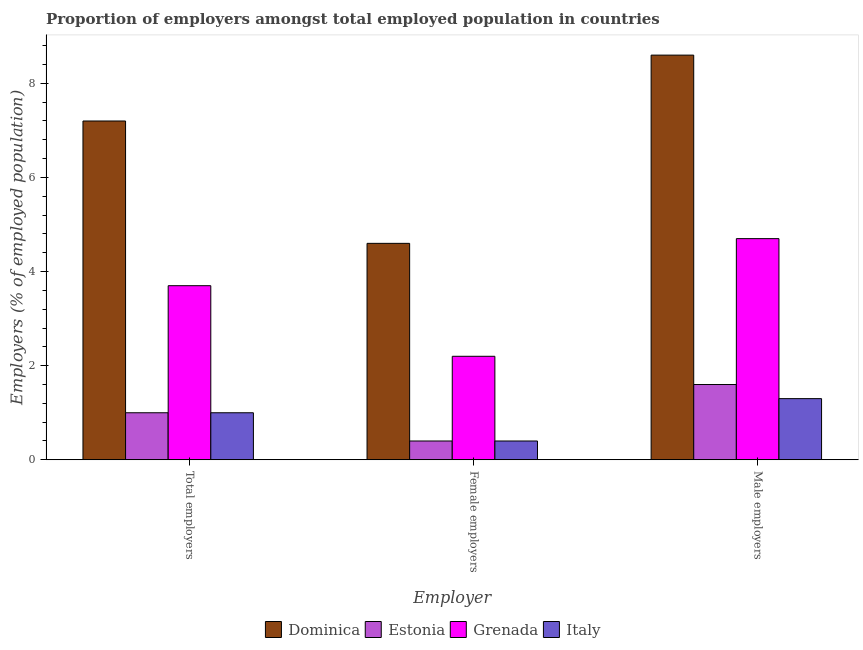How many groups of bars are there?
Offer a very short reply. 3. Are the number of bars per tick equal to the number of legend labels?
Provide a succinct answer. Yes. Are the number of bars on each tick of the X-axis equal?
Your answer should be very brief. Yes. How many bars are there on the 2nd tick from the left?
Your response must be concise. 4. What is the label of the 1st group of bars from the left?
Offer a terse response. Total employers. What is the percentage of female employers in Estonia?
Give a very brief answer. 0.4. Across all countries, what is the maximum percentage of female employers?
Offer a terse response. 4.6. Across all countries, what is the minimum percentage of male employers?
Your response must be concise. 1.3. In which country was the percentage of total employers maximum?
Keep it short and to the point. Dominica. In which country was the percentage of female employers minimum?
Offer a terse response. Estonia. What is the total percentage of female employers in the graph?
Make the answer very short. 7.6. What is the difference between the percentage of male employers in Italy and that in Dominica?
Offer a terse response. -7.3. What is the difference between the percentage of male employers in Dominica and the percentage of total employers in Estonia?
Provide a short and direct response. 7.6. What is the average percentage of male employers per country?
Offer a terse response. 4.05. What is the difference between the percentage of total employers and percentage of male employers in Grenada?
Offer a terse response. -1. What is the ratio of the percentage of female employers in Italy to that in Estonia?
Offer a terse response. 1. Is the difference between the percentage of total employers in Italy and Estonia greater than the difference between the percentage of female employers in Italy and Estonia?
Provide a short and direct response. No. What is the difference between the highest and the second highest percentage of total employers?
Your answer should be compact. 3.5. What is the difference between the highest and the lowest percentage of female employers?
Your response must be concise. 4.2. In how many countries, is the percentage of male employers greater than the average percentage of male employers taken over all countries?
Make the answer very short. 2. What does the 1st bar from the left in Female employers represents?
Make the answer very short. Dominica. What does the 1st bar from the right in Male employers represents?
Your answer should be compact. Italy. Is it the case that in every country, the sum of the percentage of total employers and percentage of female employers is greater than the percentage of male employers?
Ensure brevity in your answer.  No. How many bars are there?
Your response must be concise. 12. Are all the bars in the graph horizontal?
Your answer should be very brief. No. Are the values on the major ticks of Y-axis written in scientific E-notation?
Keep it short and to the point. No. Does the graph contain any zero values?
Give a very brief answer. No. Where does the legend appear in the graph?
Give a very brief answer. Bottom center. How are the legend labels stacked?
Make the answer very short. Horizontal. What is the title of the graph?
Provide a short and direct response. Proportion of employers amongst total employed population in countries. Does "Estonia" appear as one of the legend labels in the graph?
Keep it short and to the point. Yes. What is the label or title of the X-axis?
Your response must be concise. Employer. What is the label or title of the Y-axis?
Your answer should be very brief. Employers (% of employed population). What is the Employers (% of employed population) of Dominica in Total employers?
Offer a very short reply. 7.2. What is the Employers (% of employed population) in Estonia in Total employers?
Provide a succinct answer. 1. What is the Employers (% of employed population) of Grenada in Total employers?
Offer a terse response. 3.7. What is the Employers (% of employed population) of Italy in Total employers?
Offer a very short reply. 1. What is the Employers (% of employed population) of Dominica in Female employers?
Offer a very short reply. 4.6. What is the Employers (% of employed population) of Estonia in Female employers?
Give a very brief answer. 0.4. What is the Employers (% of employed population) of Grenada in Female employers?
Your answer should be compact. 2.2. What is the Employers (% of employed population) in Italy in Female employers?
Your answer should be compact. 0.4. What is the Employers (% of employed population) of Dominica in Male employers?
Your answer should be compact. 8.6. What is the Employers (% of employed population) of Estonia in Male employers?
Give a very brief answer. 1.6. What is the Employers (% of employed population) in Grenada in Male employers?
Your answer should be compact. 4.7. What is the Employers (% of employed population) in Italy in Male employers?
Ensure brevity in your answer.  1.3. Across all Employer, what is the maximum Employers (% of employed population) in Dominica?
Your answer should be very brief. 8.6. Across all Employer, what is the maximum Employers (% of employed population) in Estonia?
Offer a very short reply. 1.6. Across all Employer, what is the maximum Employers (% of employed population) of Grenada?
Ensure brevity in your answer.  4.7. Across all Employer, what is the maximum Employers (% of employed population) of Italy?
Make the answer very short. 1.3. Across all Employer, what is the minimum Employers (% of employed population) of Dominica?
Make the answer very short. 4.6. Across all Employer, what is the minimum Employers (% of employed population) of Estonia?
Your answer should be very brief. 0.4. Across all Employer, what is the minimum Employers (% of employed population) of Grenada?
Your response must be concise. 2.2. Across all Employer, what is the minimum Employers (% of employed population) in Italy?
Give a very brief answer. 0.4. What is the total Employers (% of employed population) of Dominica in the graph?
Your response must be concise. 20.4. What is the total Employers (% of employed population) in Italy in the graph?
Provide a short and direct response. 2.7. What is the difference between the Employers (% of employed population) of Dominica in Total employers and that in Female employers?
Offer a terse response. 2.6. What is the difference between the Employers (% of employed population) of Estonia in Total employers and that in Female employers?
Provide a succinct answer. 0.6. What is the difference between the Employers (% of employed population) of Grenada in Total employers and that in Female employers?
Provide a short and direct response. 1.5. What is the difference between the Employers (% of employed population) in Italy in Total employers and that in Female employers?
Keep it short and to the point. 0.6. What is the difference between the Employers (% of employed population) in Estonia in Total employers and that in Male employers?
Offer a very short reply. -0.6. What is the difference between the Employers (% of employed population) of Italy in Total employers and that in Male employers?
Ensure brevity in your answer.  -0.3. What is the difference between the Employers (% of employed population) in Dominica in Female employers and that in Male employers?
Your answer should be compact. -4. What is the difference between the Employers (% of employed population) of Estonia in Female employers and that in Male employers?
Provide a succinct answer. -1.2. What is the difference between the Employers (% of employed population) of Grenada in Female employers and that in Male employers?
Your answer should be compact. -2.5. What is the difference between the Employers (% of employed population) of Italy in Female employers and that in Male employers?
Offer a very short reply. -0.9. What is the difference between the Employers (% of employed population) in Dominica in Total employers and the Employers (% of employed population) in Estonia in Female employers?
Ensure brevity in your answer.  6.8. What is the difference between the Employers (% of employed population) of Estonia in Total employers and the Employers (% of employed population) of Grenada in Female employers?
Your answer should be very brief. -1.2. What is the difference between the Employers (% of employed population) of Estonia in Total employers and the Employers (% of employed population) of Italy in Female employers?
Offer a terse response. 0.6. What is the difference between the Employers (% of employed population) of Dominica in Total employers and the Employers (% of employed population) of Estonia in Male employers?
Make the answer very short. 5.6. What is the difference between the Employers (% of employed population) in Dominica in Total employers and the Employers (% of employed population) in Grenada in Male employers?
Offer a very short reply. 2.5. What is the difference between the Employers (% of employed population) in Dominica in Female employers and the Employers (% of employed population) in Estonia in Male employers?
Give a very brief answer. 3. What is the difference between the Employers (% of employed population) in Dominica in Female employers and the Employers (% of employed population) in Grenada in Male employers?
Give a very brief answer. -0.1. What is the difference between the Employers (% of employed population) of Dominica in Female employers and the Employers (% of employed population) of Italy in Male employers?
Keep it short and to the point. 3.3. What is the difference between the Employers (% of employed population) in Estonia in Female employers and the Employers (% of employed population) in Grenada in Male employers?
Ensure brevity in your answer.  -4.3. What is the average Employers (% of employed population) of Grenada per Employer?
Offer a terse response. 3.53. What is the difference between the Employers (% of employed population) in Dominica and Employers (% of employed population) in Estonia in Total employers?
Offer a terse response. 6.2. What is the difference between the Employers (% of employed population) in Dominica and Employers (% of employed population) in Grenada in Total employers?
Your answer should be compact. 3.5. What is the difference between the Employers (% of employed population) in Estonia and Employers (% of employed population) in Italy in Total employers?
Ensure brevity in your answer.  0. What is the difference between the Employers (% of employed population) in Dominica and Employers (% of employed population) in Italy in Female employers?
Give a very brief answer. 4.2. What is the difference between the Employers (% of employed population) of Estonia and Employers (% of employed population) of Grenada in Female employers?
Make the answer very short. -1.8. What is the difference between the Employers (% of employed population) in Estonia and Employers (% of employed population) in Italy in Female employers?
Provide a short and direct response. 0. What is the difference between the Employers (% of employed population) in Grenada and Employers (% of employed population) in Italy in Female employers?
Provide a short and direct response. 1.8. What is the difference between the Employers (% of employed population) of Dominica and Employers (% of employed population) of Estonia in Male employers?
Provide a short and direct response. 7. What is the difference between the Employers (% of employed population) of Estonia and Employers (% of employed population) of Grenada in Male employers?
Your answer should be very brief. -3.1. What is the ratio of the Employers (% of employed population) in Dominica in Total employers to that in Female employers?
Make the answer very short. 1.57. What is the ratio of the Employers (% of employed population) of Estonia in Total employers to that in Female employers?
Provide a succinct answer. 2.5. What is the ratio of the Employers (% of employed population) of Grenada in Total employers to that in Female employers?
Your answer should be compact. 1.68. What is the ratio of the Employers (% of employed population) of Italy in Total employers to that in Female employers?
Keep it short and to the point. 2.5. What is the ratio of the Employers (% of employed population) of Dominica in Total employers to that in Male employers?
Give a very brief answer. 0.84. What is the ratio of the Employers (% of employed population) in Estonia in Total employers to that in Male employers?
Offer a terse response. 0.62. What is the ratio of the Employers (% of employed population) in Grenada in Total employers to that in Male employers?
Ensure brevity in your answer.  0.79. What is the ratio of the Employers (% of employed population) in Italy in Total employers to that in Male employers?
Your answer should be very brief. 0.77. What is the ratio of the Employers (% of employed population) in Dominica in Female employers to that in Male employers?
Provide a short and direct response. 0.53. What is the ratio of the Employers (% of employed population) in Grenada in Female employers to that in Male employers?
Keep it short and to the point. 0.47. What is the ratio of the Employers (% of employed population) in Italy in Female employers to that in Male employers?
Provide a succinct answer. 0.31. What is the difference between the highest and the second highest Employers (% of employed population) of Dominica?
Provide a succinct answer. 1.4. What is the difference between the highest and the second highest Employers (% of employed population) in Estonia?
Offer a terse response. 0.6. What is the difference between the highest and the second highest Employers (% of employed population) of Grenada?
Provide a short and direct response. 1. What is the difference between the highest and the second highest Employers (% of employed population) of Italy?
Make the answer very short. 0.3. What is the difference between the highest and the lowest Employers (% of employed population) of Dominica?
Offer a terse response. 4. What is the difference between the highest and the lowest Employers (% of employed population) of Estonia?
Offer a terse response. 1.2. What is the difference between the highest and the lowest Employers (% of employed population) in Grenada?
Provide a short and direct response. 2.5. What is the difference between the highest and the lowest Employers (% of employed population) of Italy?
Your answer should be compact. 0.9. 